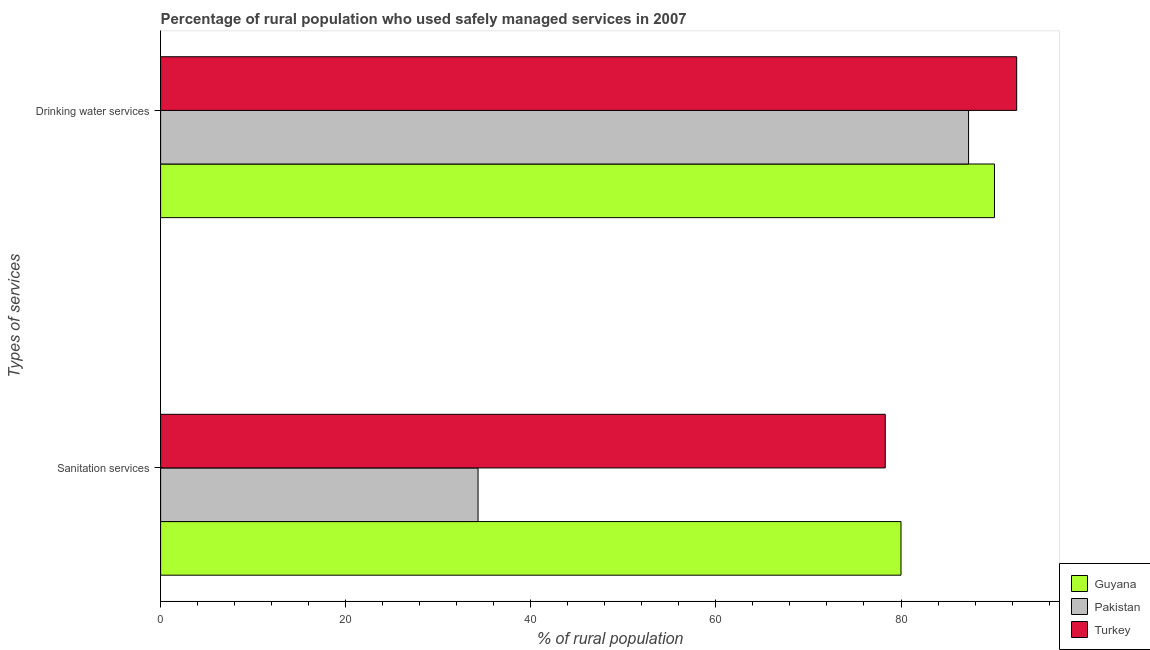How many different coloured bars are there?
Your answer should be very brief. 3. How many bars are there on the 2nd tick from the top?
Your response must be concise. 3. What is the label of the 2nd group of bars from the top?
Your answer should be very brief. Sanitation services. What is the percentage of rural population who used drinking water services in Guyana?
Provide a short and direct response. 90.1. Across all countries, what is the maximum percentage of rural population who used drinking water services?
Your answer should be compact. 92.5. Across all countries, what is the minimum percentage of rural population who used sanitation services?
Ensure brevity in your answer.  34.3. In which country was the percentage of rural population who used sanitation services maximum?
Offer a terse response. Guyana. In which country was the percentage of rural population who used drinking water services minimum?
Your answer should be compact. Pakistan. What is the total percentage of rural population who used sanitation services in the graph?
Your response must be concise. 192.6. What is the difference between the percentage of rural population who used drinking water services in Pakistan and that in Guyana?
Offer a very short reply. -2.8. What is the difference between the percentage of rural population who used sanitation services in Pakistan and the percentage of rural population who used drinking water services in Guyana?
Provide a succinct answer. -55.8. What is the average percentage of rural population who used drinking water services per country?
Ensure brevity in your answer.  89.97. What is the difference between the percentage of rural population who used drinking water services and percentage of rural population who used sanitation services in Turkey?
Offer a very short reply. 14.2. In how many countries, is the percentage of rural population who used sanitation services greater than 4 %?
Keep it short and to the point. 3. What is the ratio of the percentage of rural population who used sanitation services in Guyana to that in Turkey?
Make the answer very short. 1.02. What does the 3rd bar from the top in Drinking water services represents?
Your response must be concise. Guyana. How many bars are there?
Offer a very short reply. 6. How many countries are there in the graph?
Your response must be concise. 3. Does the graph contain grids?
Your answer should be very brief. No. How many legend labels are there?
Your response must be concise. 3. What is the title of the graph?
Make the answer very short. Percentage of rural population who used safely managed services in 2007. What is the label or title of the X-axis?
Offer a very short reply. % of rural population. What is the label or title of the Y-axis?
Your response must be concise. Types of services. What is the % of rural population of Pakistan in Sanitation services?
Ensure brevity in your answer.  34.3. What is the % of rural population in Turkey in Sanitation services?
Ensure brevity in your answer.  78.3. What is the % of rural population of Guyana in Drinking water services?
Your answer should be compact. 90.1. What is the % of rural population of Pakistan in Drinking water services?
Your answer should be very brief. 87.3. What is the % of rural population of Turkey in Drinking water services?
Offer a very short reply. 92.5. Across all Types of services, what is the maximum % of rural population of Guyana?
Make the answer very short. 90.1. Across all Types of services, what is the maximum % of rural population of Pakistan?
Ensure brevity in your answer.  87.3. Across all Types of services, what is the maximum % of rural population of Turkey?
Make the answer very short. 92.5. Across all Types of services, what is the minimum % of rural population of Guyana?
Your response must be concise. 80. Across all Types of services, what is the minimum % of rural population of Pakistan?
Ensure brevity in your answer.  34.3. Across all Types of services, what is the minimum % of rural population of Turkey?
Your response must be concise. 78.3. What is the total % of rural population of Guyana in the graph?
Your answer should be compact. 170.1. What is the total % of rural population in Pakistan in the graph?
Make the answer very short. 121.6. What is the total % of rural population in Turkey in the graph?
Ensure brevity in your answer.  170.8. What is the difference between the % of rural population in Pakistan in Sanitation services and that in Drinking water services?
Provide a succinct answer. -53. What is the difference between the % of rural population in Pakistan in Sanitation services and the % of rural population in Turkey in Drinking water services?
Keep it short and to the point. -58.2. What is the average % of rural population in Guyana per Types of services?
Your response must be concise. 85.05. What is the average % of rural population in Pakistan per Types of services?
Your response must be concise. 60.8. What is the average % of rural population of Turkey per Types of services?
Provide a succinct answer. 85.4. What is the difference between the % of rural population of Guyana and % of rural population of Pakistan in Sanitation services?
Your response must be concise. 45.7. What is the difference between the % of rural population of Pakistan and % of rural population of Turkey in Sanitation services?
Ensure brevity in your answer.  -44. What is the difference between the % of rural population of Guyana and % of rural population of Pakistan in Drinking water services?
Offer a very short reply. 2.8. What is the difference between the % of rural population in Pakistan and % of rural population in Turkey in Drinking water services?
Offer a very short reply. -5.2. What is the ratio of the % of rural population of Guyana in Sanitation services to that in Drinking water services?
Your answer should be very brief. 0.89. What is the ratio of the % of rural population in Pakistan in Sanitation services to that in Drinking water services?
Offer a very short reply. 0.39. What is the ratio of the % of rural population in Turkey in Sanitation services to that in Drinking water services?
Your answer should be very brief. 0.85. What is the difference between the highest and the second highest % of rural population in Guyana?
Keep it short and to the point. 10.1. What is the difference between the highest and the lowest % of rural population in Turkey?
Make the answer very short. 14.2. 